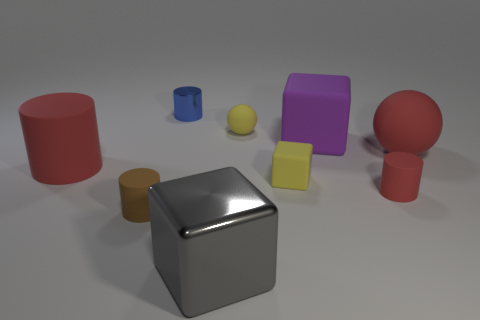What color is the small matte object behind the red matte sphere?
Your answer should be compact. Yellow. Do the red rubber cylinder that is on the left side of the purple matte thing and the small cube have the same size?
Ensure brevity in your answer.  No. What is the size of the ball that is the same color as the large cylinder?
Give a very brief answer. Large. Is there a thing of the same size as the shiny cube?
Make the answer very short. Yes. There is a rubber block that is in front of the big matte cylinder; is its color the same as the tiny rubber object that is behind the purple rubber thing?
Offer a terse response. Yes. Is there a object that has the same color as the large rubber ball?
Your response must be concise. Yes. How many other objects are the same shape as the gray shiny thing?
Provide a succinct answer. 2. There is a small matte thing behind the yellow rubber cube; what shape is it?
Provide a short and direct response. Sphere. There is a brown thing; does it have the same shape as the red thing that is to the left of the tiny blue thing?
Offer a terse response. Yes. How big is the cube that is in front of the big red ball and to the right of the gray shiny block?
Your answer should be compact. Small. 